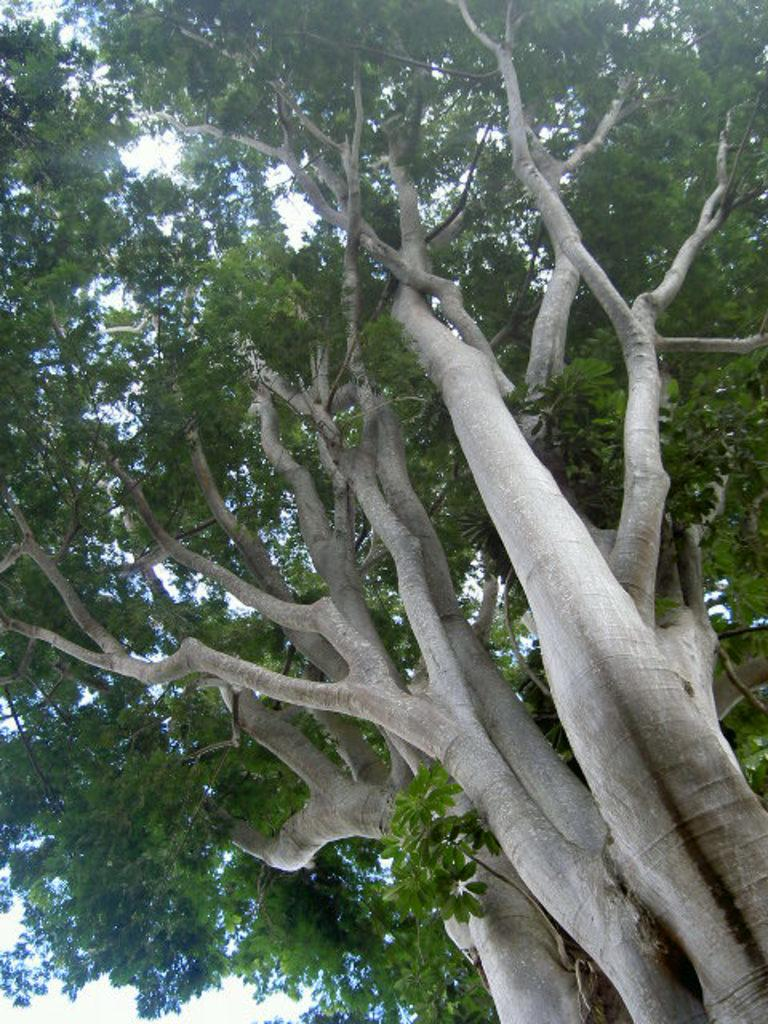What type of vegetation is visible in the image? There are trees in the image. Can you see a face carved into the bark of any tree in the image? There is no mention of a carved face in the image, so it cannot be determined from the provided fact. 